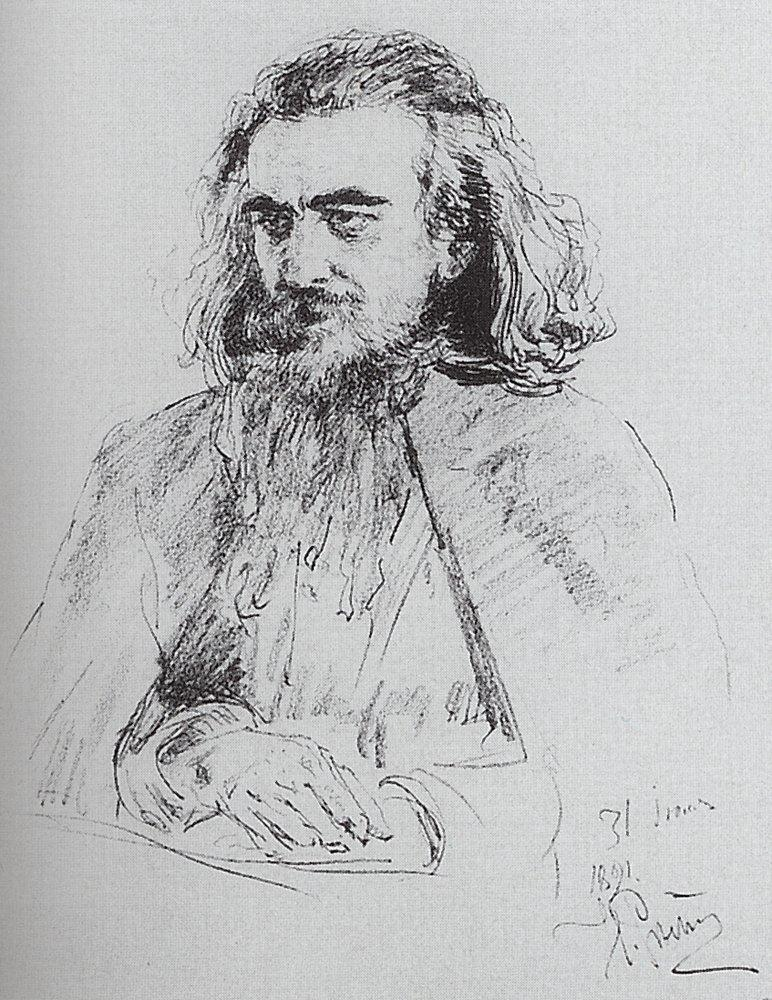What emotions does this sketch evoke in you? This sketch evokes a sense of tranquility and deep introspection. The thoughtful expression on the man's face, coupled with the soft, flowing lines, conveys a quiet moment of contemplation. The overall atmosphere of the drawing is serene and reflective, inviting the viewer to share in the subject's solitude and ponder the thoughts that might occupy his mind. Could this sketch tell a story about the man's life? Indeed, this sketch could tell many stories about the man's life. His appearance—a full beard, long hair, and a thoughtful demeanor—hints at a life of wisdom and perhaps intellectual pursuit. The detailed attention to his expression suggests a man who has seen much and spent a great deal of time in reflection. One could imagine him as a philosopher, writer, or artist, someone who has dedicated much of his life to contemplative endeavors. The serene, somewhat somber expression might hint at profound experiences, possibly struggles or great personal achievements, that have left a lasting impact on his spirit. The black and white palette adds a timeless quality, suggesting that the themes of his life are universal and enduring. 